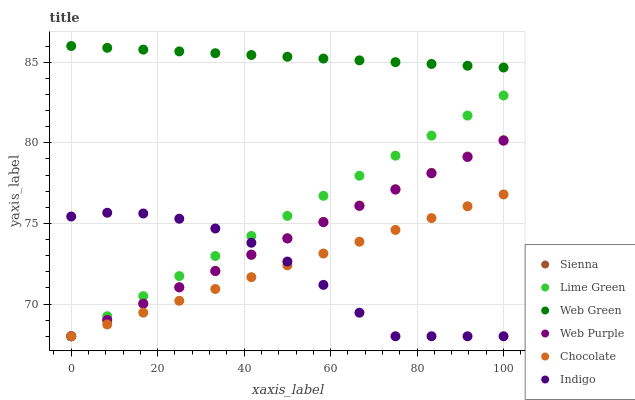Does Indigo have the minimum area under the curve?
Answer yes or no. Yes. Does Web Green have the maximum area under the curve?
Answer yes or no. Yes. Does Chocolate have the minimum area under the curve?
Answer yes or no. No. Does Chocolate have the maximum area under the curve?
Answer yes or no. No. Is Sienna the smoothest?
Answer yes or no. Yes. Is Indigo the roughest?
Answer yes or no. Yes. Is Web Green the smoothest?
Answer yes or no. No. Is Web Green the roughest?
Answer yes or no. No. Does Indigo have the lowest value?
Answer yes or no. Yes. Does Web Green have the lowest value?
Answer yes or no. No. Does Web Green have the highest value?
Answer yes or no. Yes. Does Chocolate have the highest value?
Answer yes or no. No. Is Chocolate less than Web Green?
Answer yes or no. Yes. Is Web Green greater than Lime Green?
Answer yes or no. Yes. Does Lime Green intersect Chocolate?
Answer yes or no. Yes. Is Lime Green less than Chocolate?
Answer yes or no. No. Is Lime Green greater than Chocolate?
Answer yes or no. No. Does Chocolate intersect Web Green?
Answer yes or no. No. 